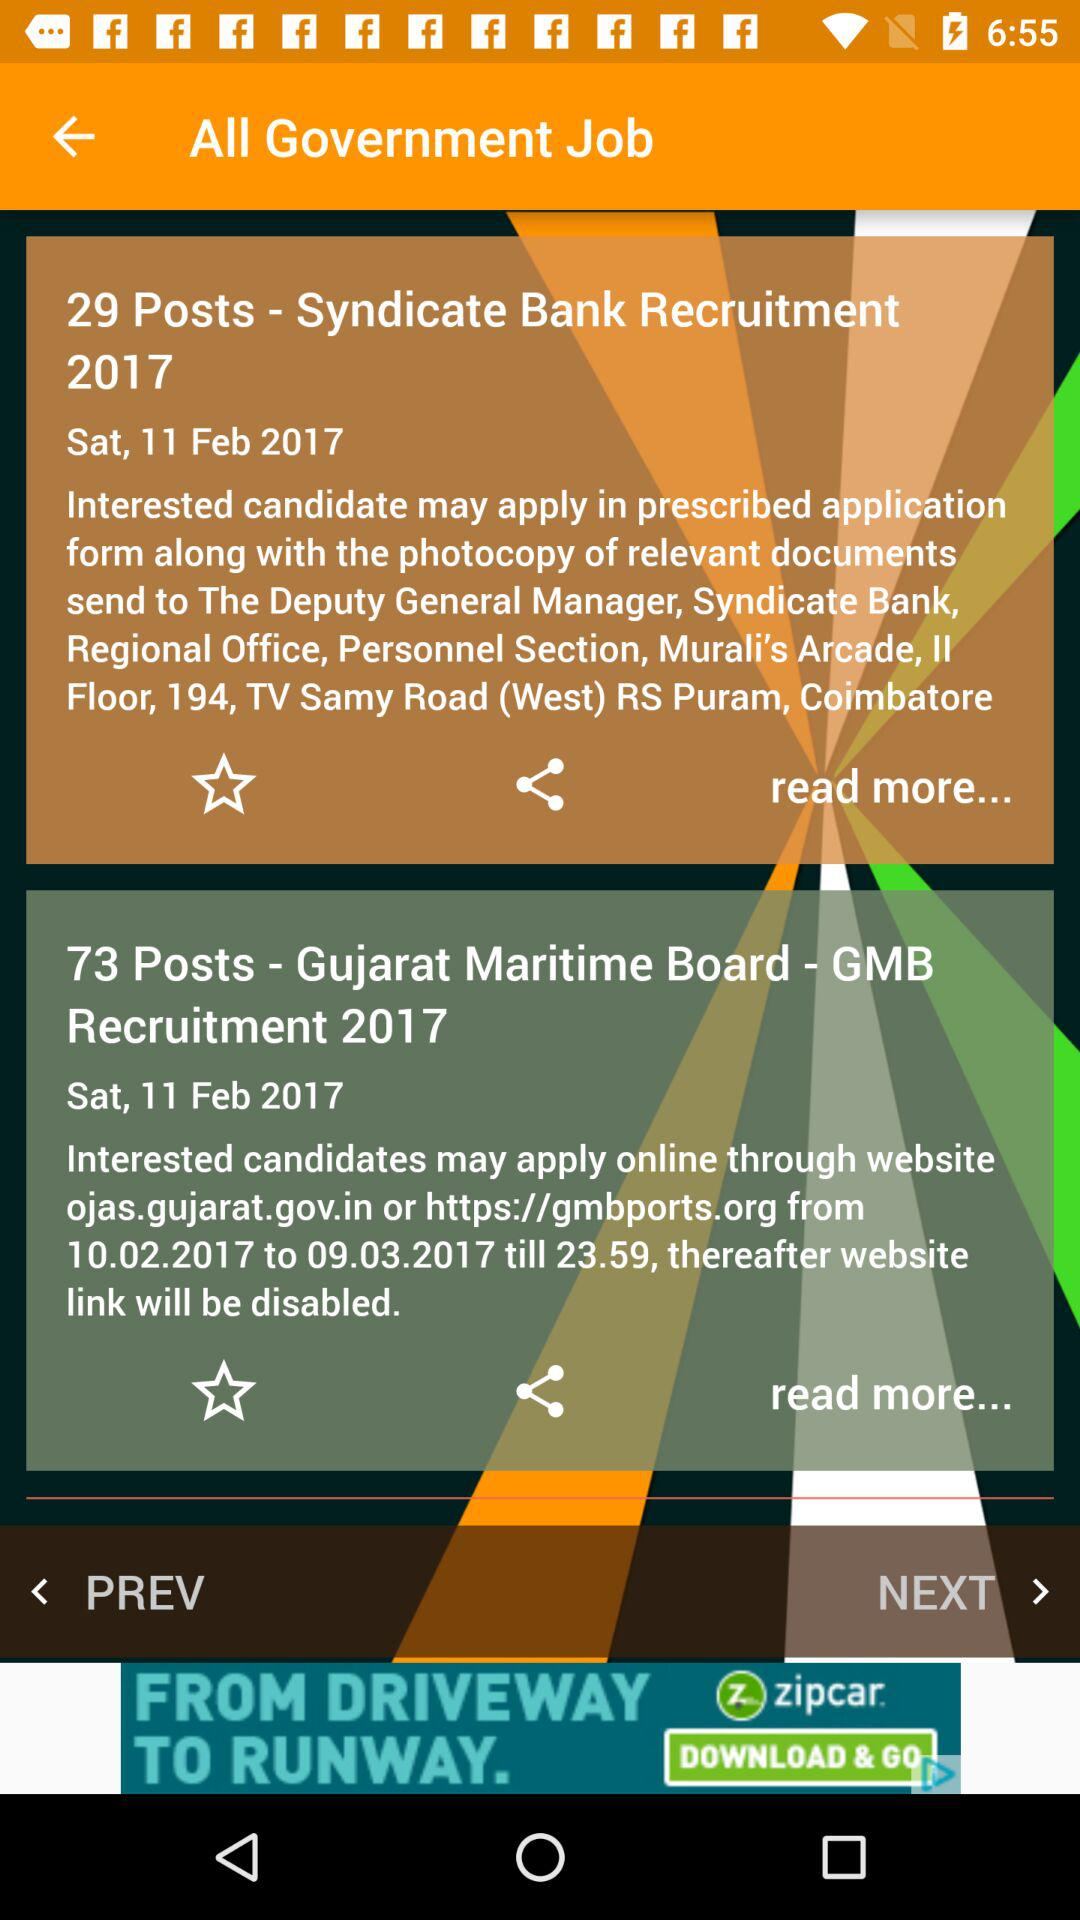What is the date of the post "Syndicate Bank Recruitment 2017"? The date is Saturday, February 11, 2017. 